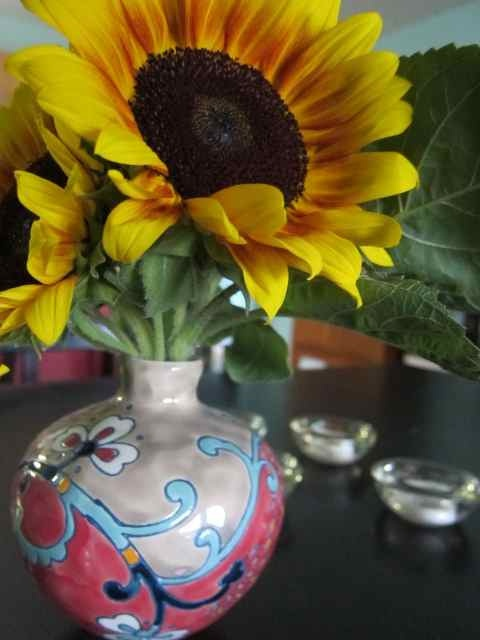Describe the objects in this image and their specific colors. I can see potted plant in darkgray, black, and olive tones, dining table in darkgray, black, gray, and purple tones, vase in darkgray, gray, lightgray, and brown tones, bowl in darkgray, gray, and black tones, and bowl in darkgray, gray, and black tones in this image. 